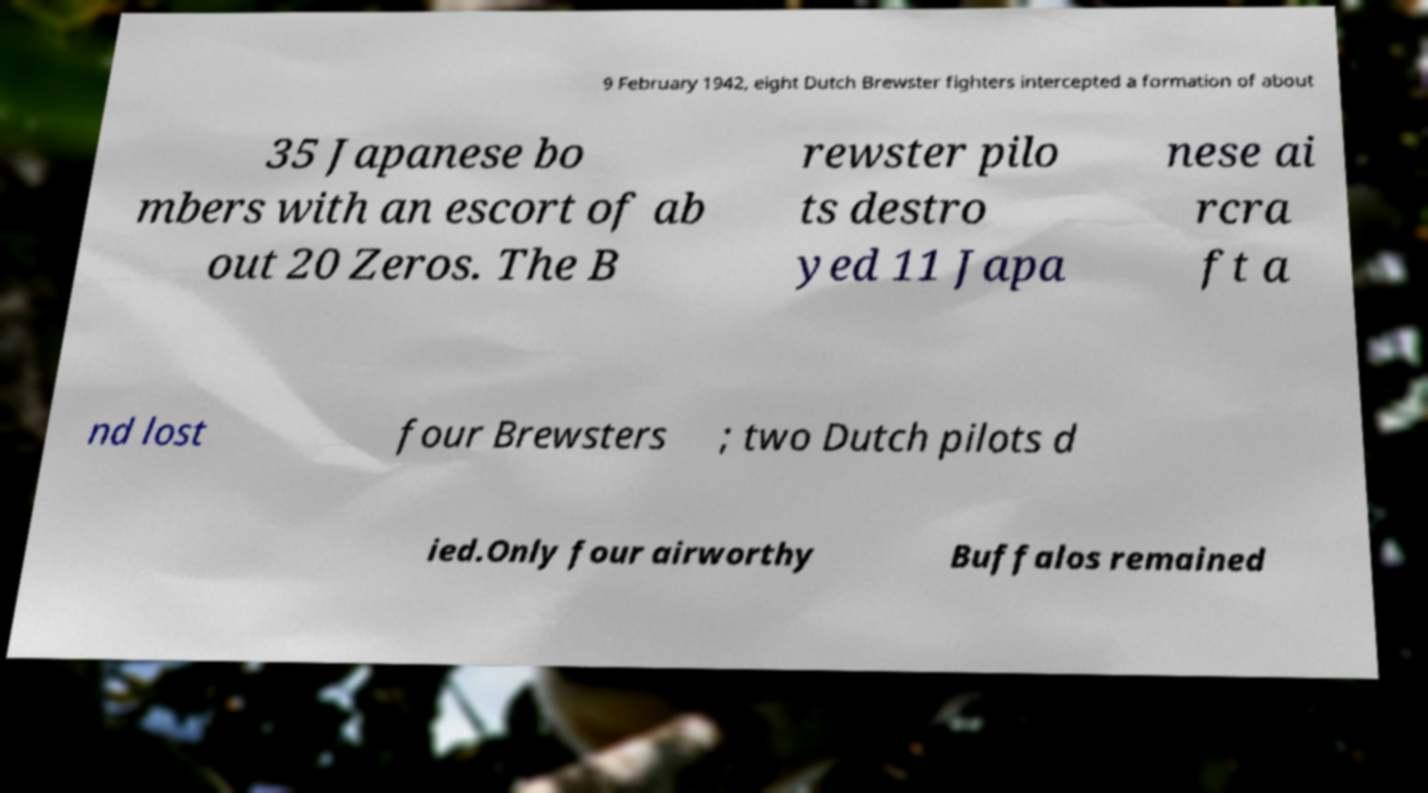Please read and relay the text visible in this image. What does it say? 9 February 1942, eight Dutch Brewster fighters intercepted a formation of about 35 Japanese bo mbers with an escort of ab out 20 Zeros. The B rewster pilo ts destro yed 11 Japa nese ai rcra ft a nd lost four Brewsters ; two Dutch pilots d ied.Only four airworthy Buffalos remained 